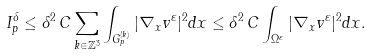<formula> <loc_0><loc_0><loc_500><loc_500>I ^ { \delta } _ { p } \leq \delta ^ { 2 } \, C \sum _ { k \in \mathbb { Z } ^ { 3 } } \int _ { G _ { p } ^ { ( k ) } } | \nabla _ { x } v ^ { \varepsilon } | ^ { 2 } d x \leq \delta ^ { 2 } \, C \int _ { \Omega ^ { \varepsilon } } | \nabla _ { x } v ^ { \varepsilon } | ^ { 2 } d x .</formula> 